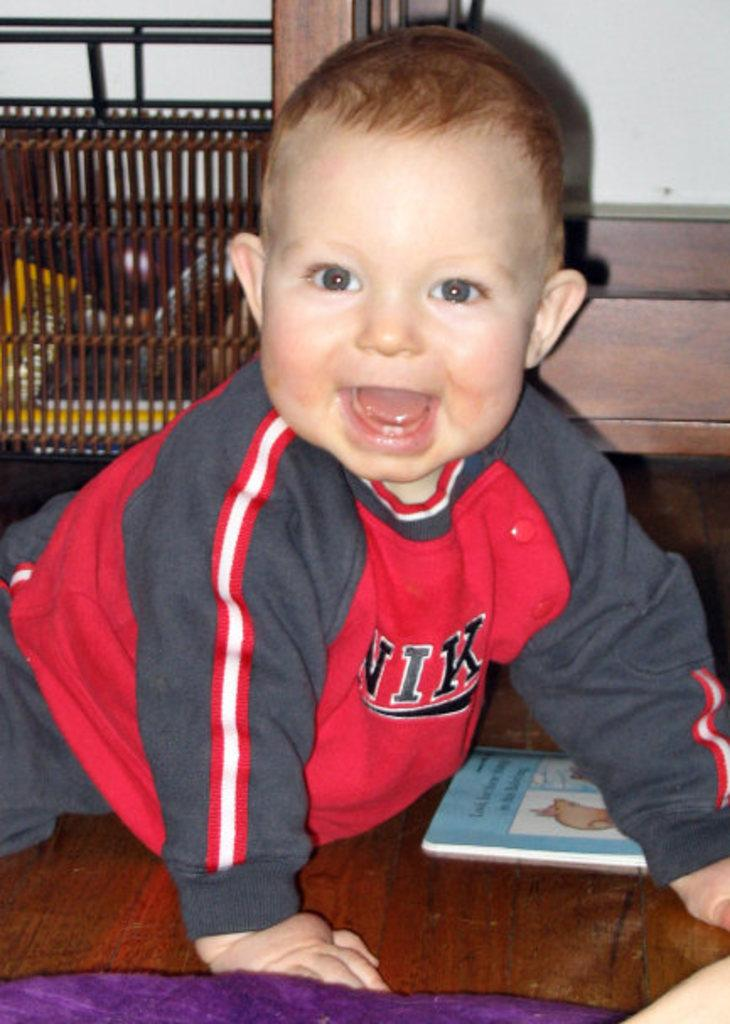<image>
Offer a succinct explanation of the picture presented. Crawling and smiling blond toddler wearing red Nike shirt 